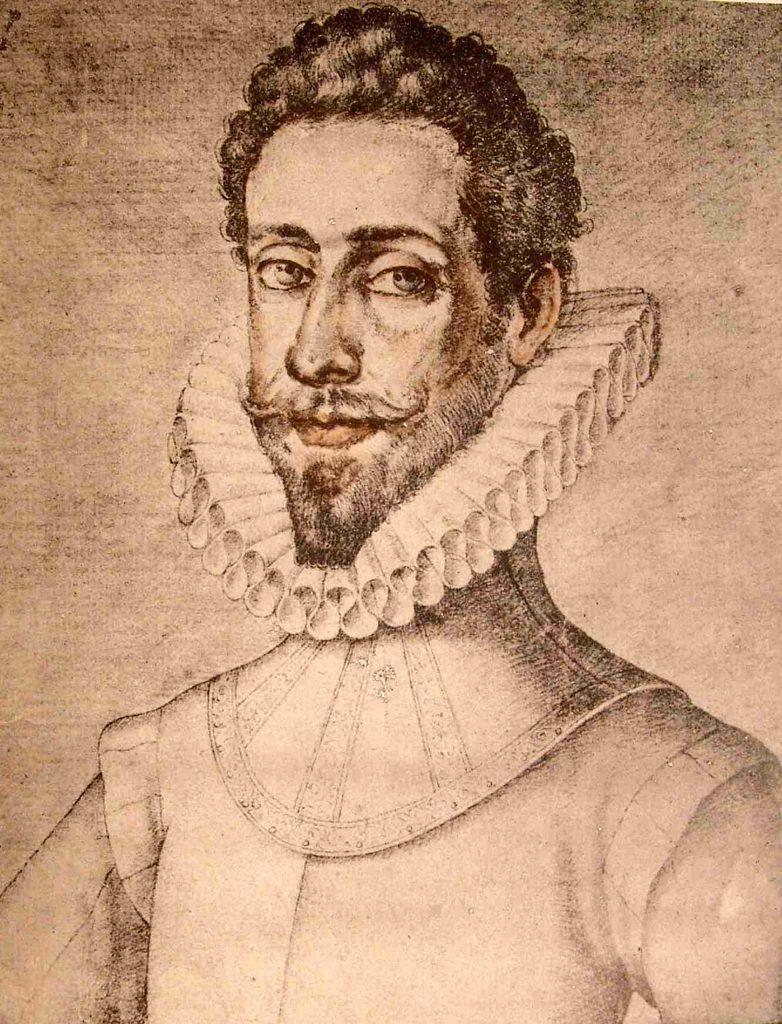What is the main subject of the image? There is a depiction of a man in the image. What colors are used in the image? The image is brown and white in color. How many bells are hanging around the man's neck in the image? There are no bells present in the image; it only depicts a man. What type of suggestion is the man making in the image? The image does not convey any suggestions or actions; it is a static depiction of a man. 